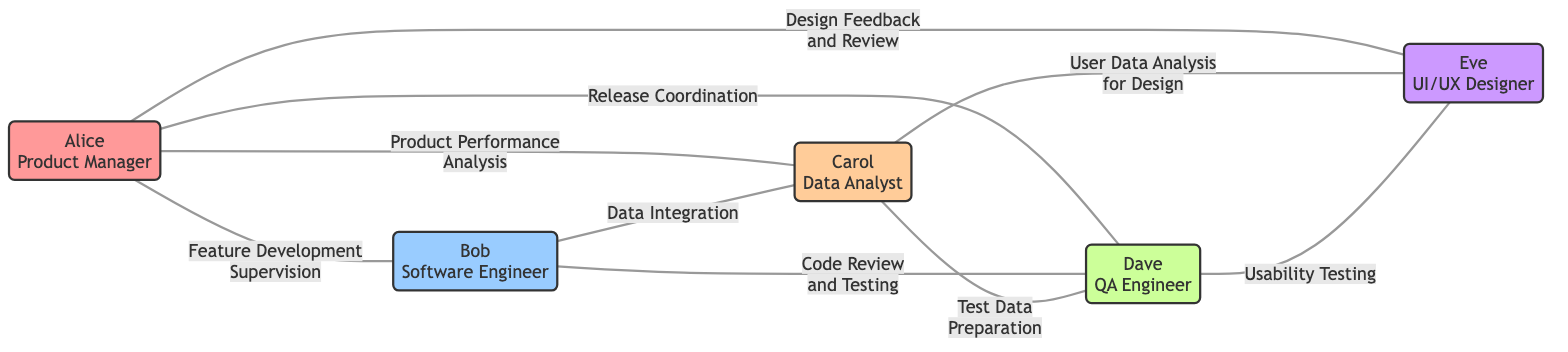What is the role of Alice? Alice is identified as the Product Manager in the diagram.
Answer: Product Manager How many total nodes are in the graph? The graph lists five team members as nodes: Alice, Bob, Carol, Dave, and Eve, which totals to five nodes.
Answer: 5 What task connects Bob and Carol? The edge between Bob and Carol is labeled "Data Integration," indicating this specific task connects them.
Answer: Data Integration Which team member has the most connections? Alice has four edges connecting her to other team members, making her the member with the most connections in the graph.
Answer: Alice What is the relationship between Carol and Dave? Carol and Dave are connected by the edge labeled "Test Data Preparation," representing a working relationship focused on this task.
Answer: Test Data Preparation How many tasks does Eve oversee? Eve is connected to two other team members (Alice and Carol) through tasks, indicating she oversees two tasks related to her roles.
Answer: 2 Which task involves usability testing? The edge between Dave and Eve is labeled "Usability Testing," which refers specifically to this task.
Answer: Usability Testing How many edges are in the graph? The total number of edges (tasks) listed in the graph is eight, representing connections among team members.
Answer: 8 What is the primary oversight task Alice has over Bob? The task connecting Alice and Bob is labeled "Feature Development Supervision," indicating her oversight in this area.
Answer: Feature Development Supervision 